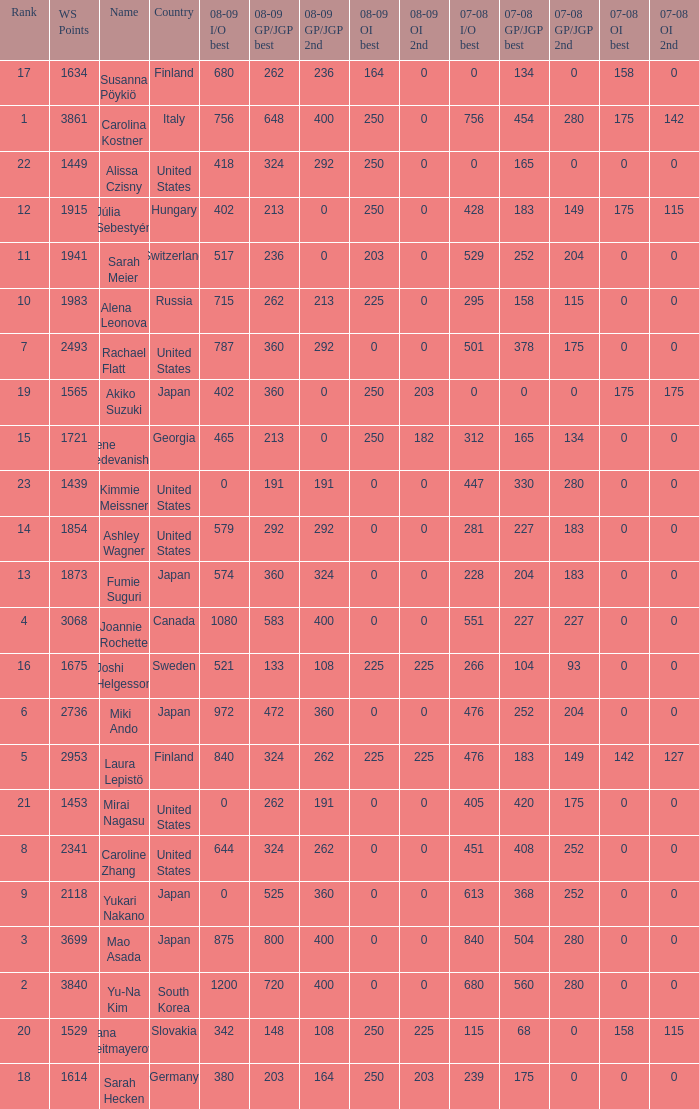08-09 gp/jgp 2nd is 213 and ws points will be what maximum 1983.0. 